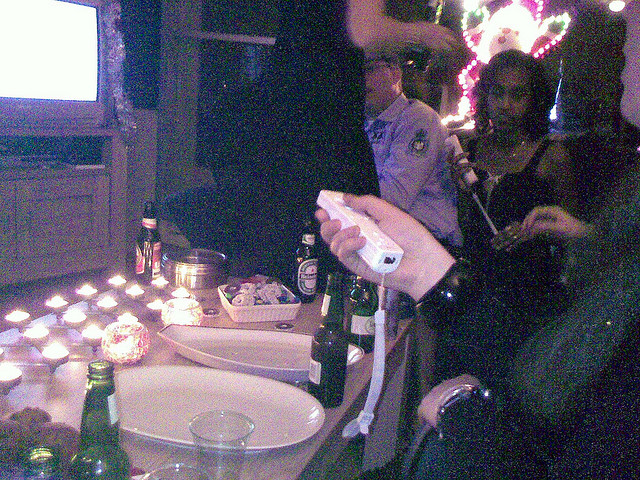<image>What kind of beer is on the table? I am not sure what kind of beer is on the table. It can be 'molson', 'heineken', 'busch', 'bud light', 'bottled', 'budweiser' or 'unknown'. What kind of beer is on the table? I am not sure what kind of beer is on the table. 